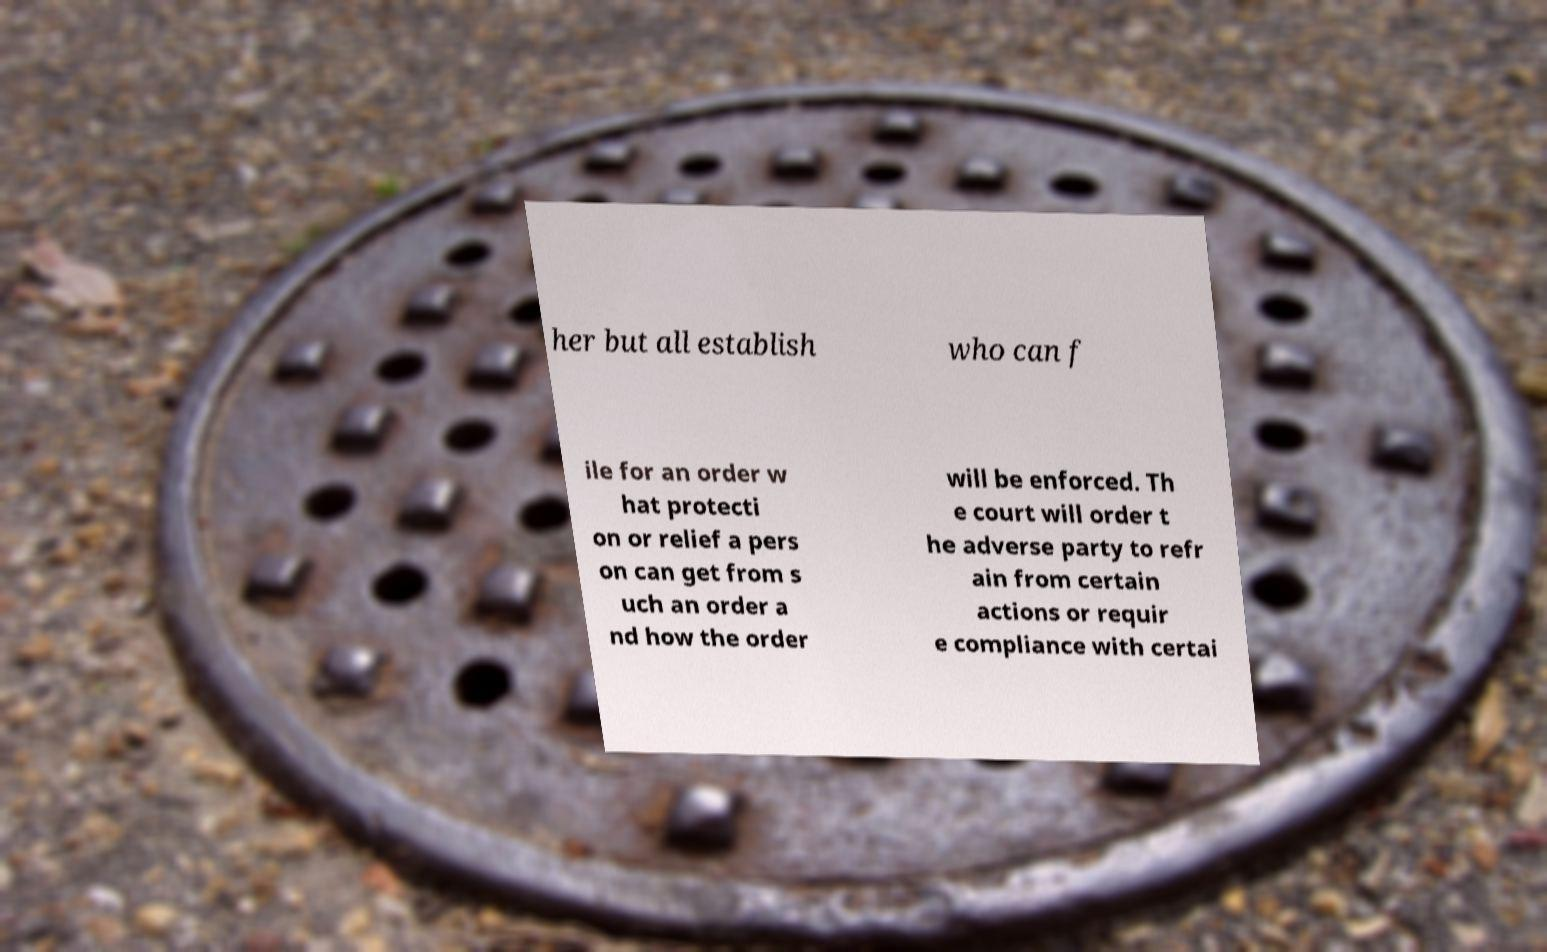What messages or text are displayed in this image? I need them in a readable, typed format. her but all establish who can f ile for an order w hat protecti on or relief a pers on can get from s uch an order a nd how the order will be enforced. Th e court will order t he adverse party to refr ain from certain actions or requir e compliance with certai 